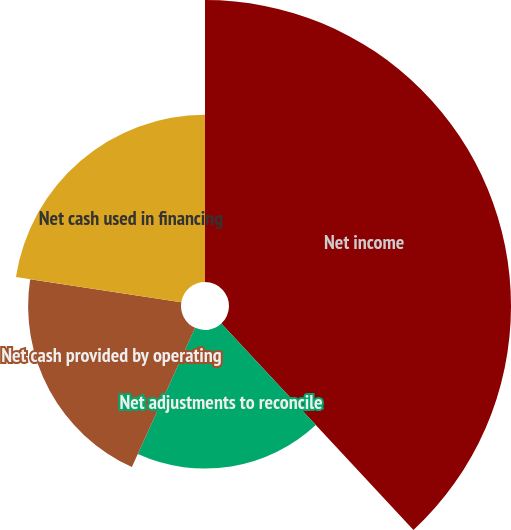Convert chart to OTSL. <chart><loc_0><loc_0><loc_500><loc_500><pie_chart><fcel>Net income<fcel>Net adjustments to reconcile<fcel>Net cash provided by operating<fcel>Net cash used in financing<nl><fcel>38.07%<fcel>18.71%<fcel>20.64%<fcel>22.58%<nl></chart> 